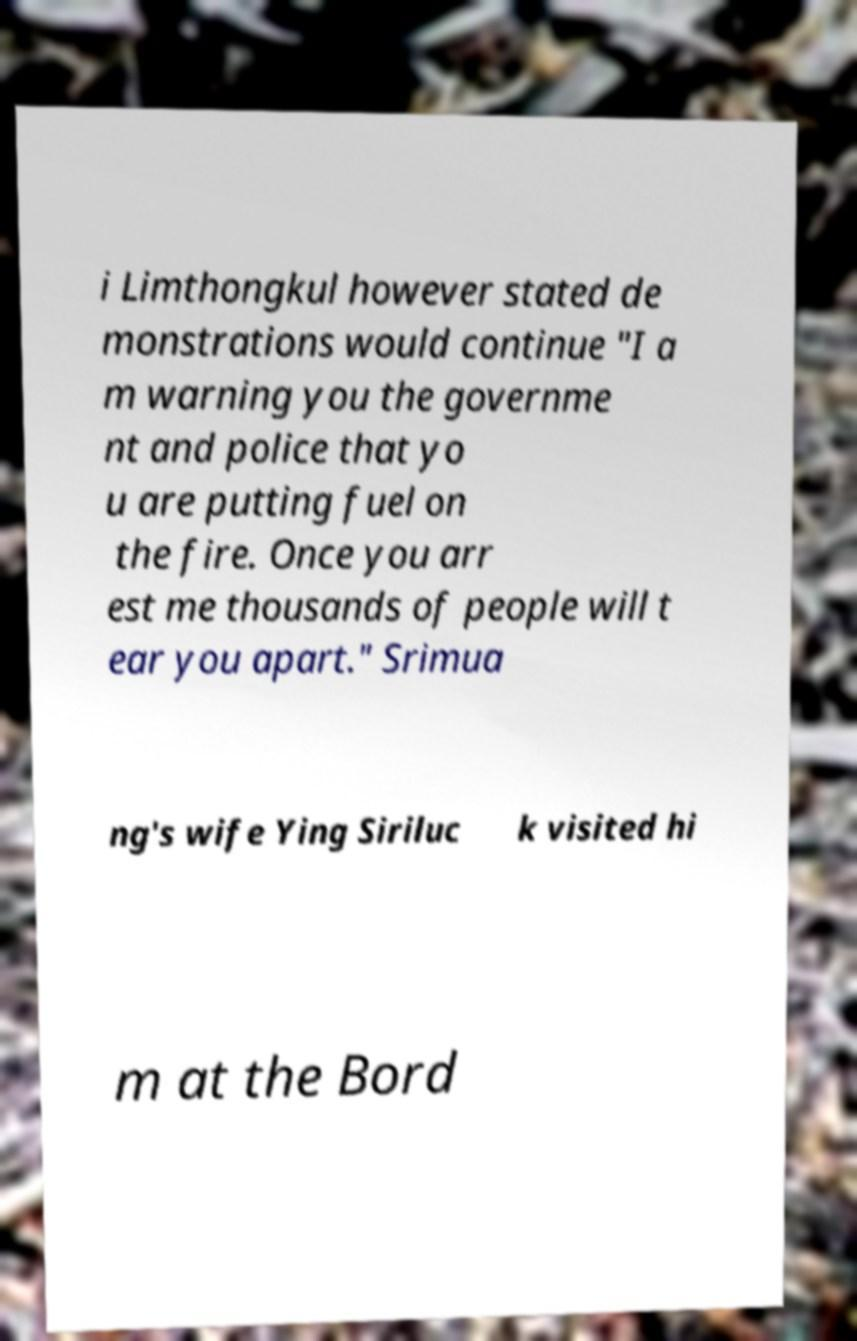There's text embedded in this image that I need extracted. Can you transcribe it verbatim? i Limthongkul however stated de monstrations would continue "I a m warning you the governme nt and police that yo u are putting fuel on the fire. Once you arr est me thousands of people will t ear you apart." Srimua ng's wife Ying Siriluc k visited hi m at the Bord 